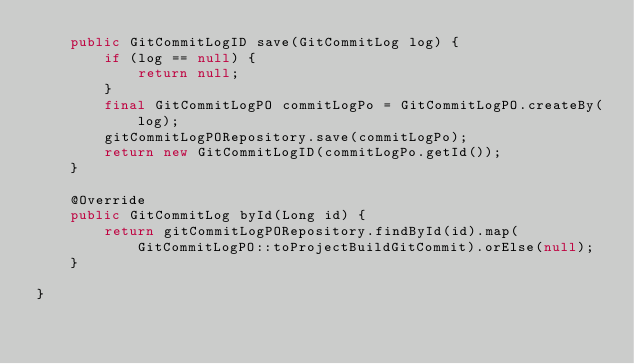<code> <loc_0><loc_0><loc_500><loc_500><_Java_>    public GitCommitLogID save(GitCommitLog log) {
        if (log == null) {
            return null;
        }
        final GitCommitLogPO commitLogPo = GitCommitLogPO.createBy(log);
        gitCommitLogPORepository.save(commitLogPo);
        return new GitCommitLogID(commitLogPo.getId());
    }

    @Override
    public GitCommitLog byId(Long id) {
        return gitCommitLogPORepository.findById(id).map(GitCommitLogPO::toProjectBuildGitCommit).orElse(null);
    }

}
</code> 